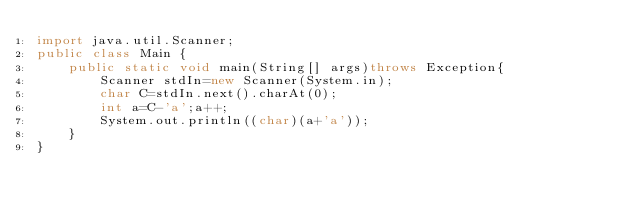Convert code to text. <code><loc_0><loc_0><loc_500><loc_500><_Java_>import java.util.Scanner;
public class Main {
	public static void main(String[] args)throws Exception{
		Scanner stdIn=new Scanner(System.in);
		char C=stdIn.next().charAt(0);
		int a=C-'a';a++;
		System.out.println((char)(a+'a'));
	}
}
</code> 